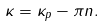<formula> <loc_0><loc_0><loc_500><loc_500>\kappa = \kappa _ { p } - \pi n .</formula> 